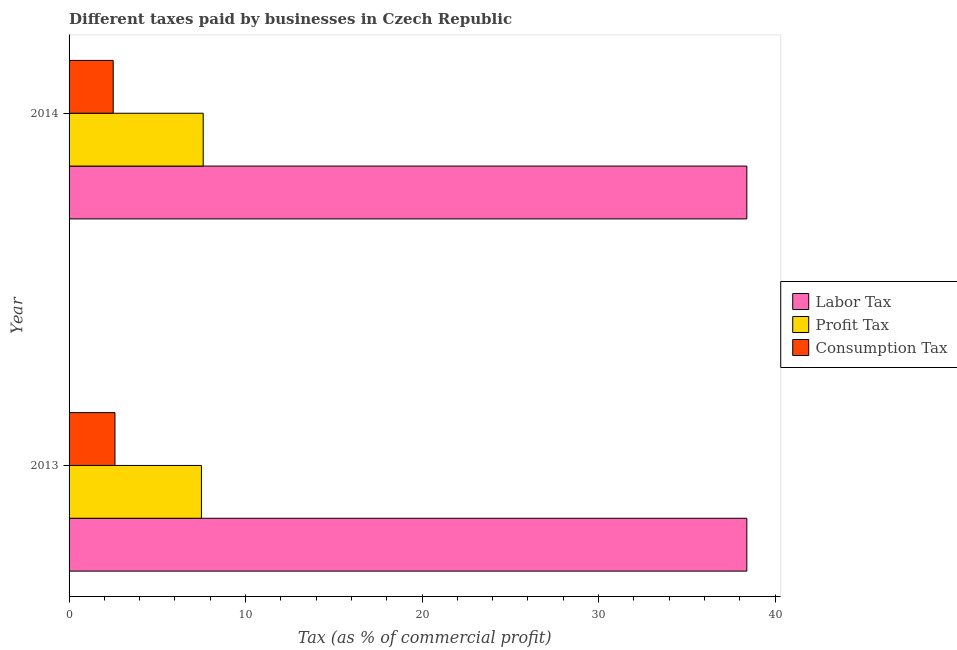Are the number of bars per tick equal to the number of legend labels?
Give a very brief answer. Yes. Are the number of bars on each tick of the Y-axis equal?
Offer a very short reply. Yes. How many bars are there on the 2nd tick from the top?
Your answer should be very brief. 3. What is the label of the 1st group of bars from the top?
Give a very brief answer. 2014. In how many cases, is the number of bars for a given year not equal to the number of legend labels?
Offer a very short reply. 0. What is the percentage of labor tax in 2013?
Ensure brevity in your answer.  38.4. Across all years, what is the minimum percentage of consumption tax?
Your answer should be very brief. 2.5. In which year was the percentage of labor tax maximum?
Your response must be concise. 2013. In which year was the percentage of profit tax minimum?
Ensure brevity in your answer.  2013. What is the total percentage of labor tax in the graph?
Offer a terse response. 76.8. What is the difference between the percentage of profit tax in 2013 and the percentage of labor tax in 2014?
Keep it short and to the point. -30.9. What is the average percentage of profit tax per year?
Ensure brevity in your answer.  7.55. In the year 2014, what is the difference between the percentage of labor tax and percentage of profit tax?
Your answer should be compact. 30.8. What is the ratio of the percentage of profit tax in 2013 to that in 2014?
Your response must be concise. 0.99. Is the percentage of consumption tax in 2013 less than that in 2014?
Your answer should be very brief. No. What does the 2nd bar from the top in 2013 represents?
Offer a very short reply. Profit Tax. What does the 2nd bar from the bottom in 2013 represents?
Your response must be concise. Profit Tax. Is it the case that in every year, the sum of the percentage of labor tax and percentage of profit tax is greater than the percentage of consumption tax?
Offer a terse response. Yes. Are all the bars in the graph horizontal?
Offer a terse response. Yes. Where does the legend appear in the graph?
Your response must be concise. Center right. What is the title of the graph?
Offer a very short reply. Different taxes paid by businesses in Czech Republic. What is the label or title of the X-axis?
Give a very brief answer. Tax (as % of commercial profit). What is the Tax (as % of commercial profit) of Labor Tax in 2013?
Offer a terse response. 38.4. What is the Tax (as % of commercial profit) in Profit Tax in 2013?
Make the answer very short. 7.5. What is the Tax (as % of commercial profit) of Labor Tax in 2014?
Keep it short and to the point. 38.4. What is the Tax (as % of commercial profit) in Profit Tax in 2014?
Offer a very short reply. 7.6. What is the Tax (as % of commercial profit) in Consumption Tax in 2014?
Make the answer very short. 2.5. Across all years, what is the maximum Tax (as % of commercial profit) in Labor Tax?
Ensure brevity in your answer.  38.4. Across all years, what is the maximum Tax (as % of commercial profit) of Consumption Tax?
Your answer should be very brief. 2.6. Across all years, what is the minimum Tax (as % of commercial profit) in Labor Tax?
Provide a succinct answer. 38.4. Across all years, what is the minimum Tax (as % of commercial profit) of Consumption Tax?
Your answer should be very brief. 2.5. What is the total Tax (as % of commercial profit) of Labor Tax in the graph?
Make the answer very short. 76.8. What is the difference between the Tax (as % of commercial profit) of Labor Tax in 2013 and that in 2014?
Give a very brief answer. 0. What is the difference between the Tax (as % of commercial profit) of Profit Tax in 2013 and that in 2014?
Provide a succinct answer. -0.1. What is the difference between the Tax (as % of commercial profit) in Consumption Tax in 2013 and that in 2014?
Your answer should be compact. 0.1. What is the difference between the Tax (as % of commercial profit) in Labor Tax in 2013 and the Tax (as % of commercial profit) in Profit Tax in 2014?
Make the answer very short. 30.8. What is the difference between the Tax (as % of commercial profit) of Labor Tax in 2013 and the Tax (as % of commercial profit) of Consumption Tax in 2014?
Keep it short and to the point. 35.9. What is the average Tax (as % of commercial profit) of Labor Tax per year?
Your answer should be very brief. 38.4. What is the average Tax (as % of commercial profit) in Profit Tax per year?
Give a very brief answer. 7.55. What is the average Tax (as % of commercial profit) in Consumption Tax per year?
Your answer should be very brief. 2.55. In the year 2013, what is the difference between the Tax (as % of commercial profit) of Labor Tax and Tax (as % of commercial profit) of Profit Tax?
Keep it short and to the point. 30.9. In the year 2013, what is the difference between the Tax (as % of commercial profit) of Labor Tax and Tax (as % of commercial profit) of Consumption Tax?
Offer a terse response. 35.8. In the year 2013, what is the difference between the Tax (as % of commercial profit) in Profit Tax and Tax (as % of commercial profit) in Consumption Tax?
Provide a short and direct response. 4.9. In the year 2014, what is the difference between the Tax (as % of commercial profit) in Labor Tax and Tax (as % of commercial profit) in Profit Tax?
Your answer should be compact. 30.8. In the year 2014, what is the difference between the Tax (as % of commercial profit) in Labor Tax and Tax (as % of commercial profit) in Consumption Tax?
Make the answer very short. 35.9. What is the ratio of the Tax (as % of commercial profit) of Profit Tax in 2013 to that in 2014?
Provide a short and direct response. 0.99. What is the ratio of the Tax (as % of commercial profit) in Consumption Tax in 2013 to that in 2014?
Offer a very short reply. 1.04. What is the difference between the highest and the second highest Tax (as % of commercial profit) of Profit Tax?
Your answer should be very brief. 0.1. What is the difference between the highest and the second highest Tax (as % of commercial profit) of Consumption Tax?
Give a very brief answer. 0.1. What is the difference between the highest and the lowest Tax (as % of commercial profit) of Consumption Tax?
Provide a short and direct response. 0.1. 